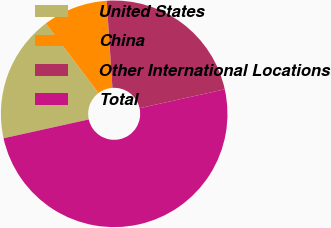Convert chart. <chart><loc_0><loc_0><loc_500><loc_500><pie_chart><fcel>United States<fcel>China<fcel>Other International Locations<fcel>Total<nl><fcel>18.15%<fcel>9.26%<fcel>22.58%<fcel>50.0%<nl></chart> 